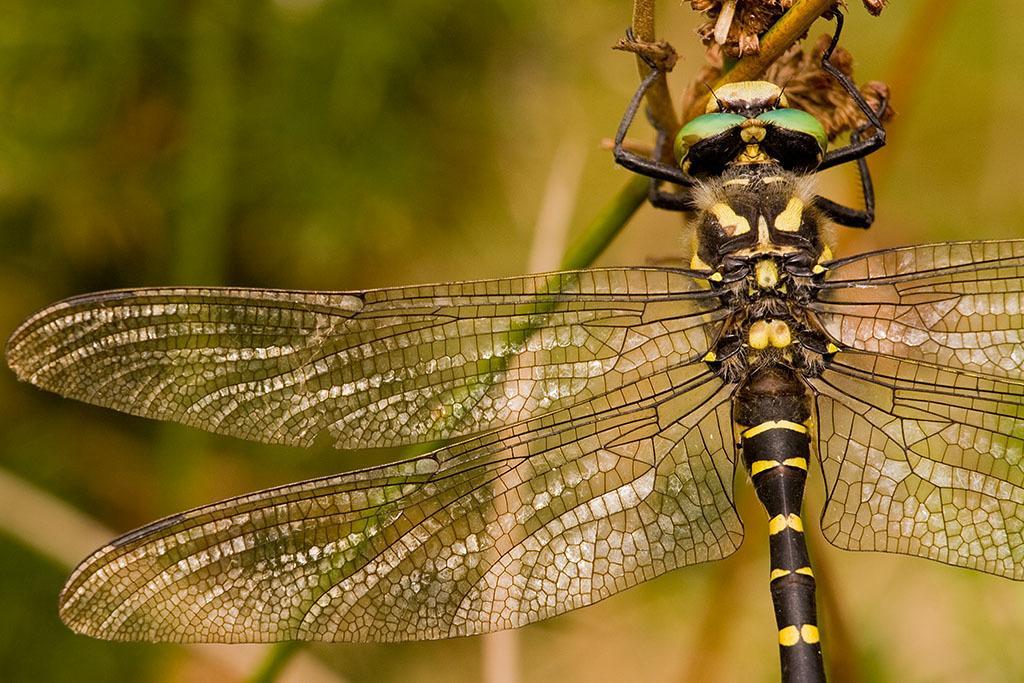Please provide a concise description of this image. In this picture there is a grasshopper who is standing on this flower. In the back I can see the blur image. 